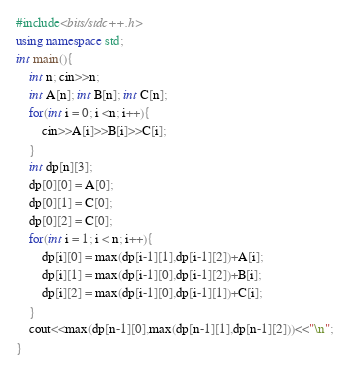<code> <loc_0><loc_0><loc_500><loc_500><_C++_>#include<bits/stdc++.h>
using namespace std;
int main(){
	int n; cin>>n;
	int A[n]; int B[n]; int C[n];
	for(int i = 0; i <n; i++){
		cin>>A[i]>>B[i]>>C[i];
	}
	int dp[n][3];
	dp[0][0] = A[0];
	dp[0][1] = C[0];
	dp[0][2] = C[0];
	for(int i = 1; i < n; i++){
		dp[i][0] = max(dp[i-1][1],dp[i-1][2])+A[i];
		dp[i][1] = max(dp[i-1][0],dp[i-1][2])+B[i];
		dp[i][2] = max(dp[i-1][0],dp[i-1][1])+C[i];
	}
	cout<<max(dp[n-1][0],max(dp[n-1][1],dp[n-1][2]))<<"\n";
}</code> 